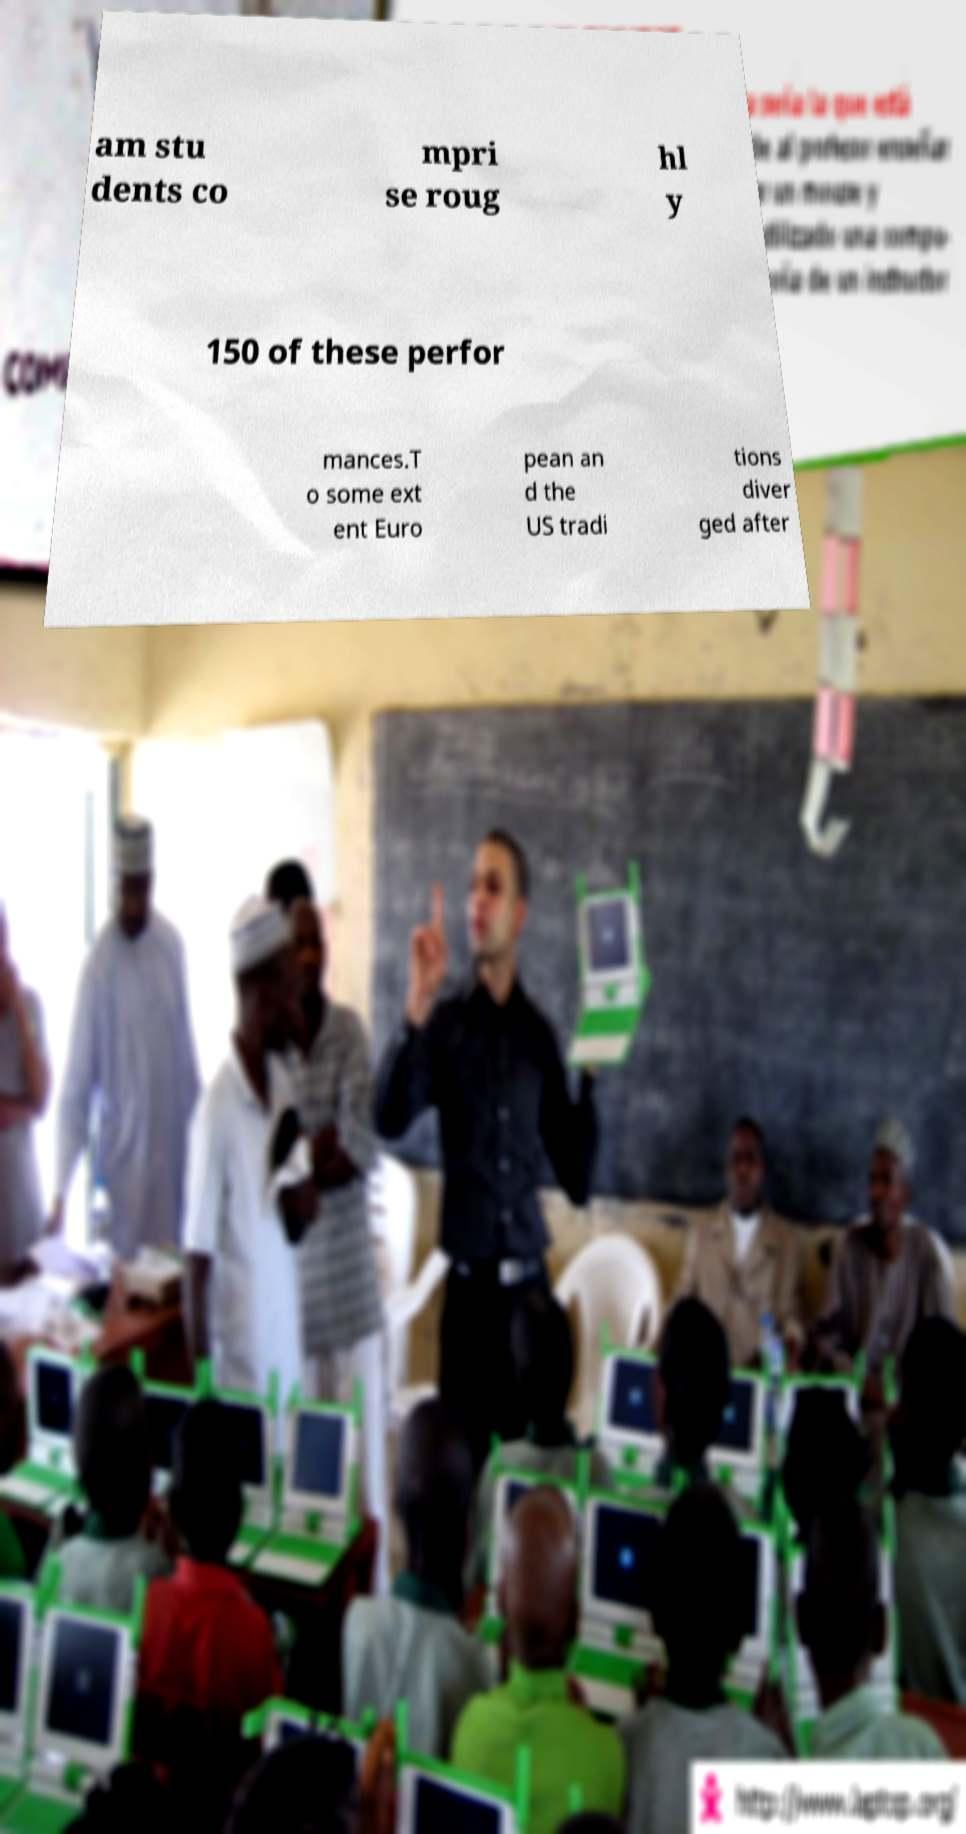Could you extract and type out the text from this image? am stu dents co mpri se roug hl y 150 of these perfor mances.T o some ext ent Euro pean an d the US tradi tions diver ged after 